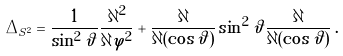Convert formula to latex. <formula><loc_0><loc_0><loc_500><loc_500>\Delta _ { S ^ { 2 } } = \frac { 1 } { \sin ^ { 2 } \vartheta } \frac { \partial ^ { 2 } } { \partial \varphi ^ { 2 } } + \frac { \partial } { \partial ( \cos \vartheta ) } \sin ^ { 2 } \vartheta \frac { \partial } { \partial ( \cos \vartheta ) } \, .</formula> 